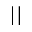<formula> <loc_0><loc_0><loc_500><loc_500>| |</formula> 